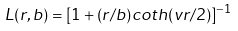Convert formula to latex. <formula><loc_0><loc_0><loc_500><loc_500>L ( r , b ) = [ 1 + ( r / b ) c o t h ( v r / 2 ) ] ^ { - 1 }</formula> 